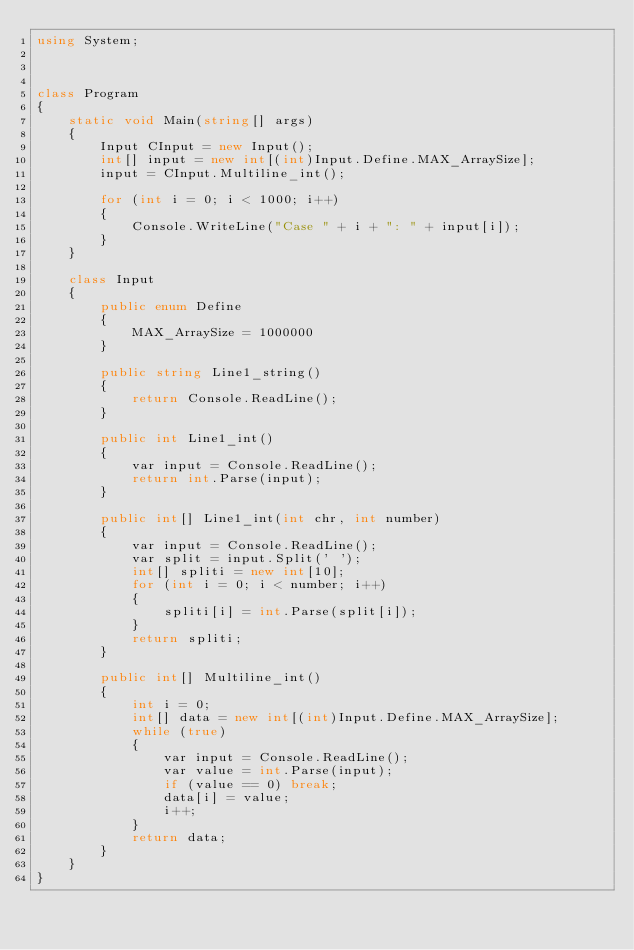Convert code to text. <code><loc_0><loc_0><loc_500><loc_500><_C#_>using System;



class Program
{
    static void Main(string[] args)
    {
        Input CInput = new Input();
        int[] input = new int[(int)Input.Define.MAX_ArraySize];
        input = CInput.Multiline_int();

        for (int i = 0; i < 1000; i++)
        {
            Console.WriteLine("Case " + i + ": " + input[i]);
        }
    }

    class Input
    {
        public enum Define
        {
            MAX_ArraySize = 1000000
        }

        public string Line1_string()
        {
            return Console.ReadLine();
        }

        public int Line1_int()
        {
            var input = Console.ReadLine();
            return int.Parse(input);
        }

        public int[] Line1_int(int chr, int number)
        {
            var input = Console.ReadLine();
            var split = input.Split(' ');
            int[] spliti = new int[10];
            for (int i = 0; i < number; i++)
            {
                spliti[i] = int.Parse(split[i]);
            }
            return spliti;
        }

        public int[] Multiline_int()
        {
            int i = 0;
            int[] data = new int[(int)Input.Define.MAX_ArraySize];
            while (true)
            {
                var input = Console.ReadLine();
                var value = int.Parse(input);
                if (value == 0) break;
                data[i] = value;
                i++;
            }
            return data;
        }
    }
}</code> 